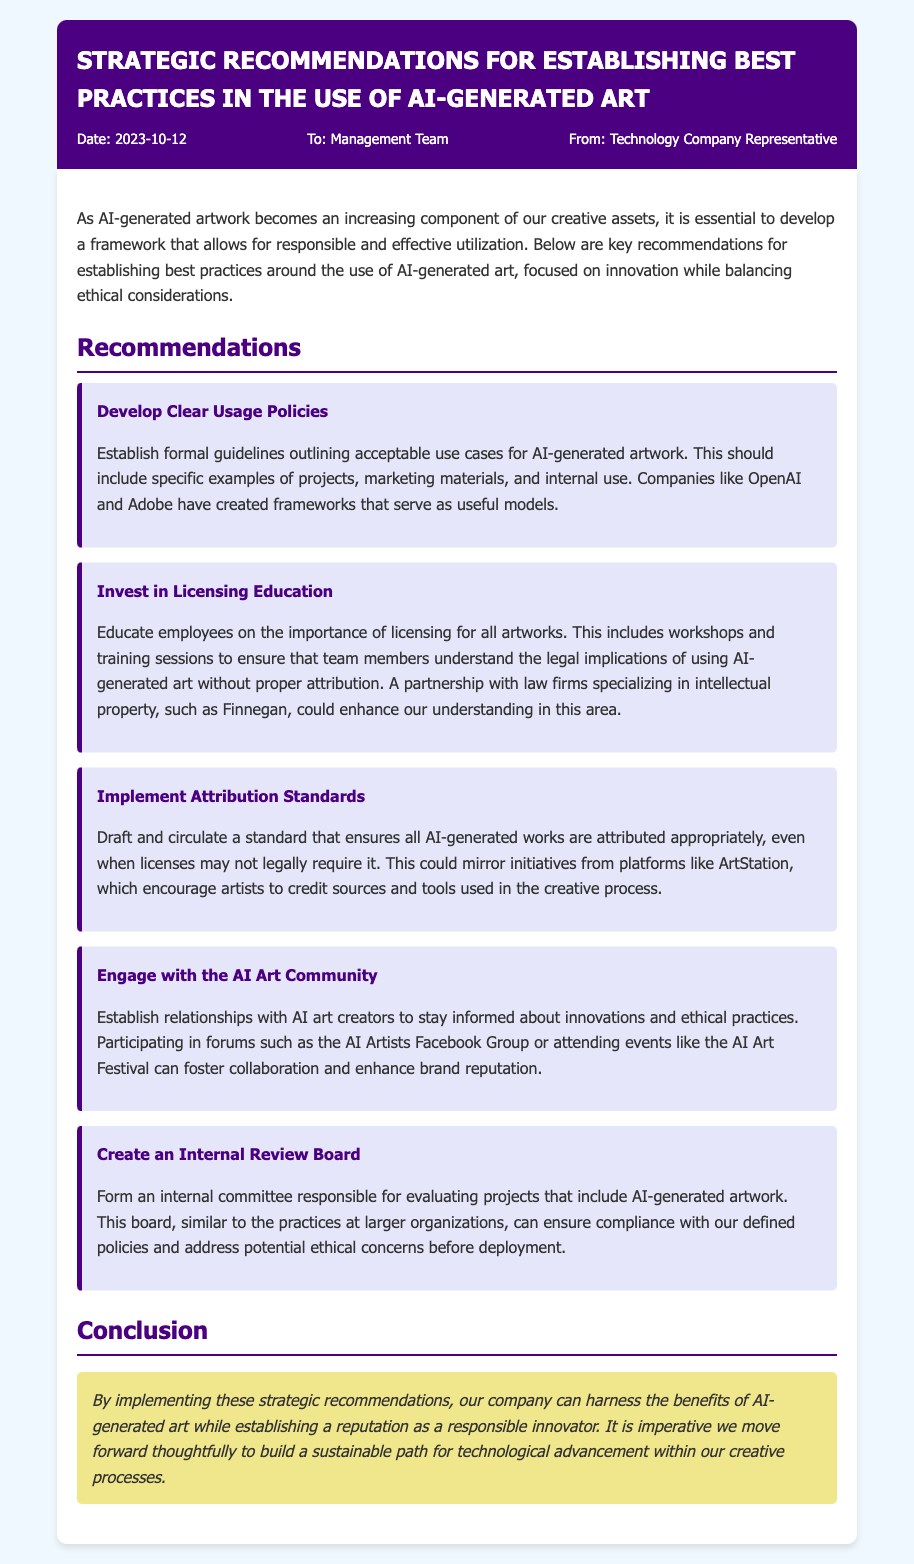What is the date of the memo? The date of the memo is mentioned in the memo header as the date when it was created.
Answer: 2023-10-12 Who is the memo addressed to? The memo includes a section in the header indicating the recipient of the memo.
Answer: Management Team What is the title of the memo? The title is stated at the top of the memo and indicates the main subject of the document.
Answer: Strategic Recommendations for Establishing Best Practices in the Use of AI-Generated Art What is one of the recommendations mentioned? The memo lists several key recommendations, each prefaced with a title, highlighting specific best practices.
Answer: Develop Clear Usage Policies How many recommendations are provided in the memo? The total number of recommendations can be counted from the section listing them in the body of the memo.
Answer: Five Which company is suggested to partner with for licensing education? The memo mentions a specialized firm that could enhance understanding of legal implications in artwork usage.
Answer: Finnegan What is the purpose of creating an internal review board? The memo describes the function of the review board in ensuring compliance with policies.
Answer: Evaluating projects that include AI-generated artwork What is encouraged regarding AI-generated works? The memo suggests a practice that pertains to acknowledging creators or sources of AI-generated artworks.
Answer: Attribution Standards What is the concluding sentiment expressed in the memo? The conclusion summarizes the overarching message of the memo regarding the approach to AI-generated art.
Answer: Responsible innovator 